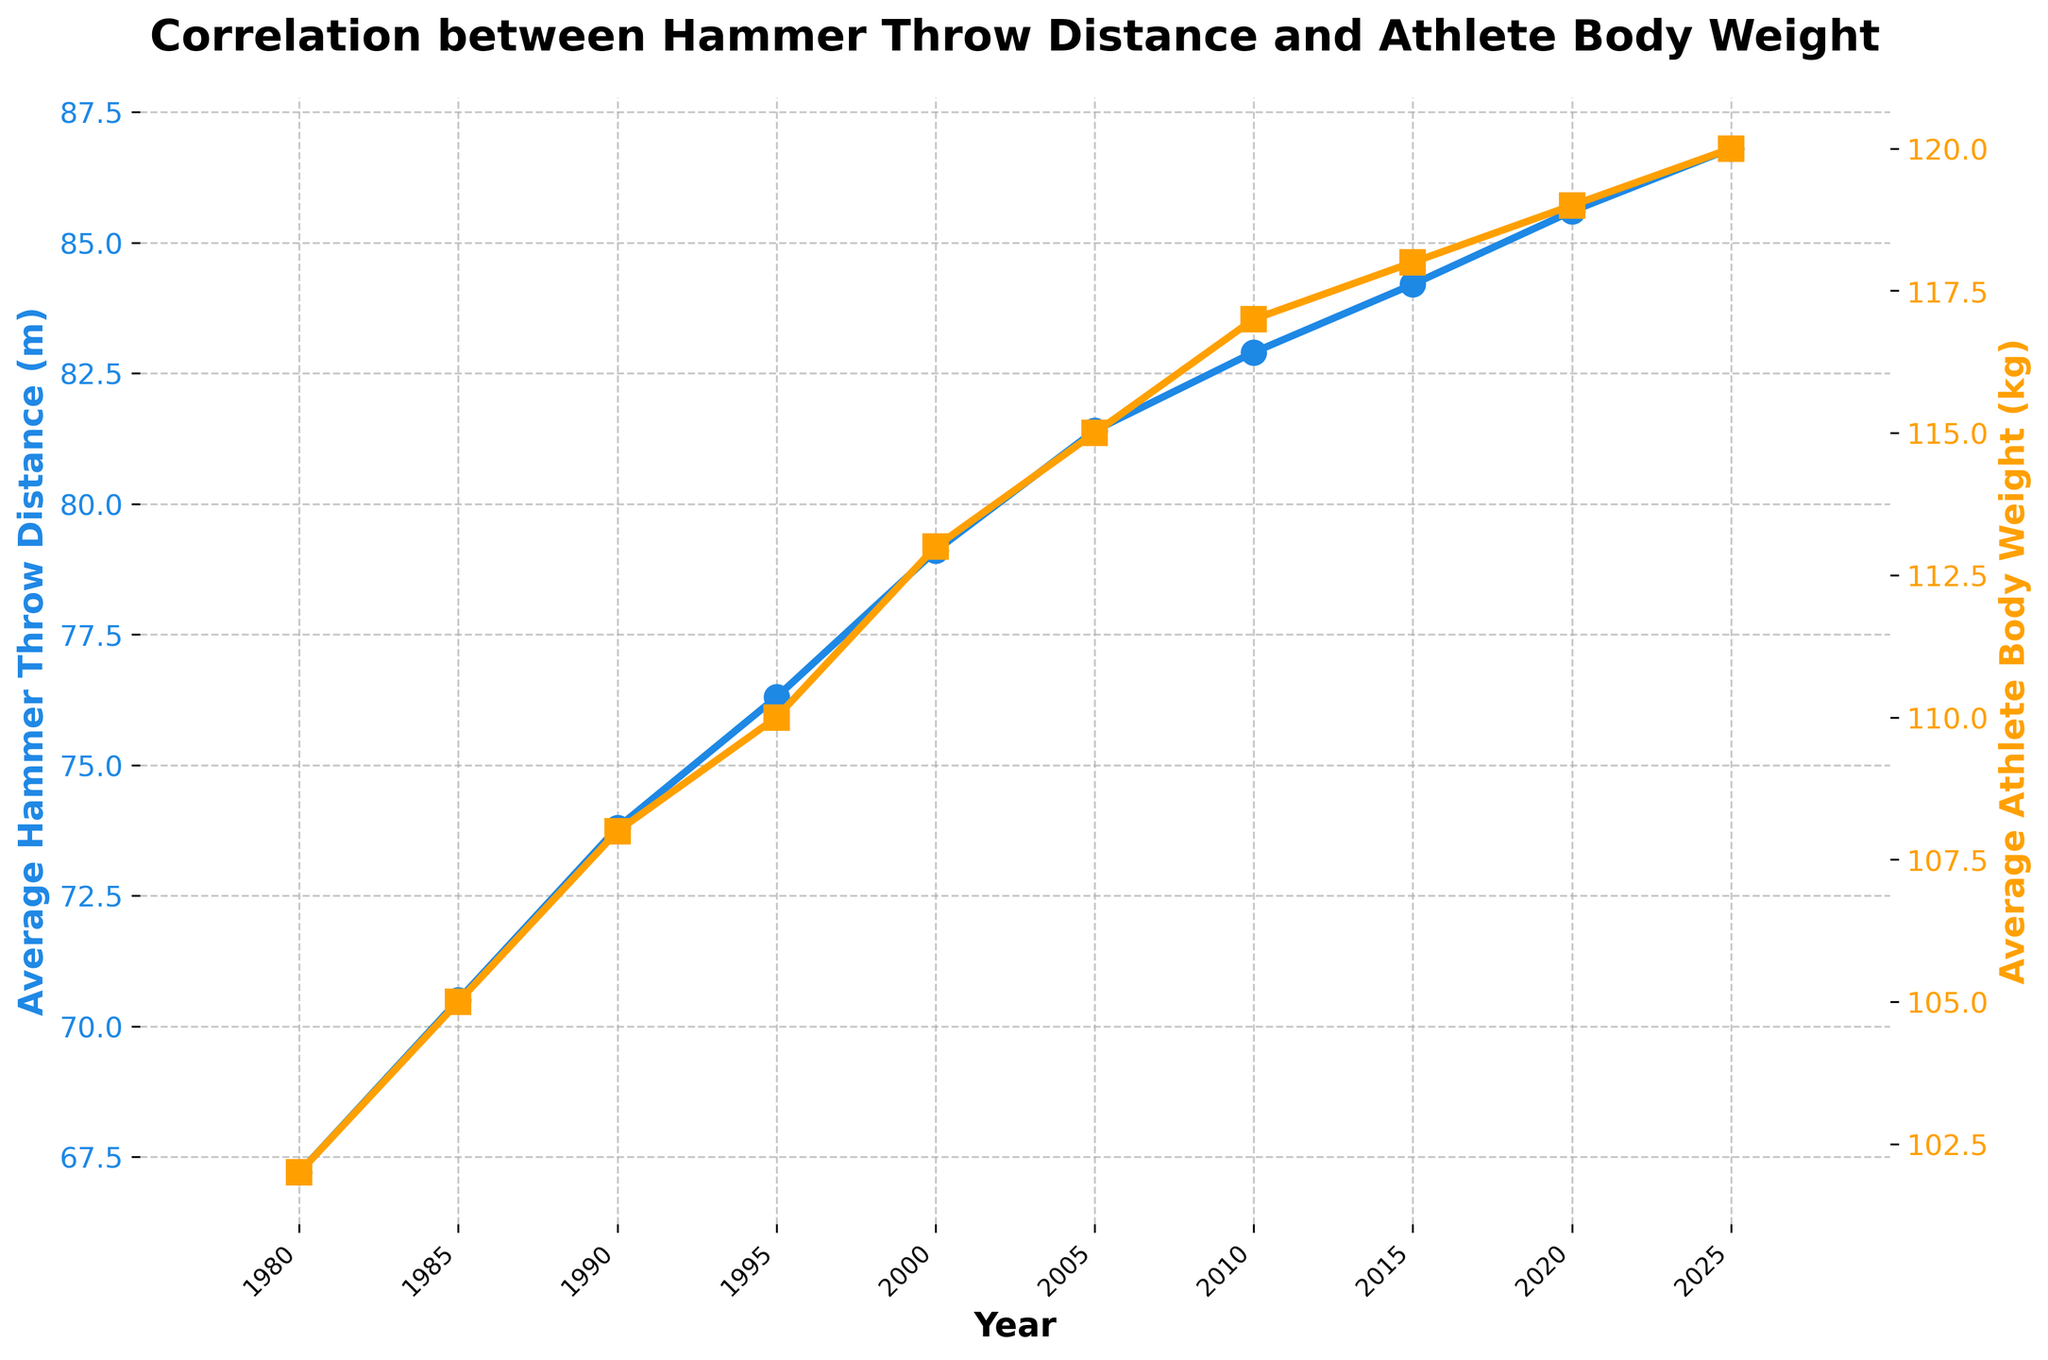what's the trend of average hammer throw distance from 1980 to 2025? From the figure, observe the line representing average hammer throw distance. It starts at 67.2 meters in 1980 and steadily increases to 86.8 meters by 2025. This consistent upward trend indicates improvement in average distances over time.
Answer: Increasing Which year shows the largest increase in average hammer throw distance compared to the previous year? Calculate the year-to-year differences in average hammer throw distances: 
1985 - 1980 = 3.3m, 
1990 - 1985 = 3.3m, 
1995 - 1990 = 2.5m, 
2000 - 1995 = 2.8m, 
2005 - 2000 = 2.3m, 
2010 - 2005 = 1.5m, 
2015 - 2010 = 1.3m, 
2020 - 2015 = 1.4m, 
2025 - 2020 = 1.2m. The largest increase is 3.3 meters observed between both 1980-1985 and 1985-1990.
Answer: 1985 What is the correlation between average hammer throw distance and average athlete body weight? Assess the relationship between the two lines on the figure: Both lines show an upward trend from 1980 to 2025. As the average athlete body weight increases, the average hammer throw distance also increases, suggesting a positive correlation.
Answer: Positive By how many kg did the average athlete body weight increase from 1980 to 2025? Find the difference between the average athlete body weight in 2025 (120 kg) and 1980 (102 kg): 120 kg - 102 kg = 18 kg.
Answer: 18 kg Is the increase in average hammer throw distances consistent throughout the years? Examine the line plot for average hammer throw distances: While the general trend is upward, the increases vary by year. The initial years (1980 to 1990) show larger incremental increases compared to later years (2010 to 2025), indicating some variability.
Answer: No What was the average hammer throw distance in the year 2000? Locate the data point for the year 2000 on the line representing average hammer throw distance: It indicates a distance of 79.1 meters.
Answer: 79.1 meters Which value is larger in 2020, the average hammer throw distance or the average athlete body weight? Compare the data points for 2020: The average hammer throw distance is 85.6 meters while the average athlete body weight is 119 kg. Since 119 is numerically larger than 85.6, the average body weight is larger.
Answer: Average athlete body weight What is the average increase in hammer throw distance per year between 1980 and 2025? Calculate the increase in average hammer throw distance over the period: (86.8m - 67.2m) / (2025 - 1980) = 19.6m / 45 years ≈ 0.44 meters per year.
Answer: 0.44 meters per year How many years did it take for the average hammer throw distance to increase by 10 meters starting from 1980? Identify when the increase achieved 77.2 meters (67.2 + 10): In 1995, the distance is 76.3 meters, and in 2000, it is 79.1 meters. Thus, the increase occurred between 1980 and 1995, taking 15 years (1980 to 1995).
Answer: 15 years 